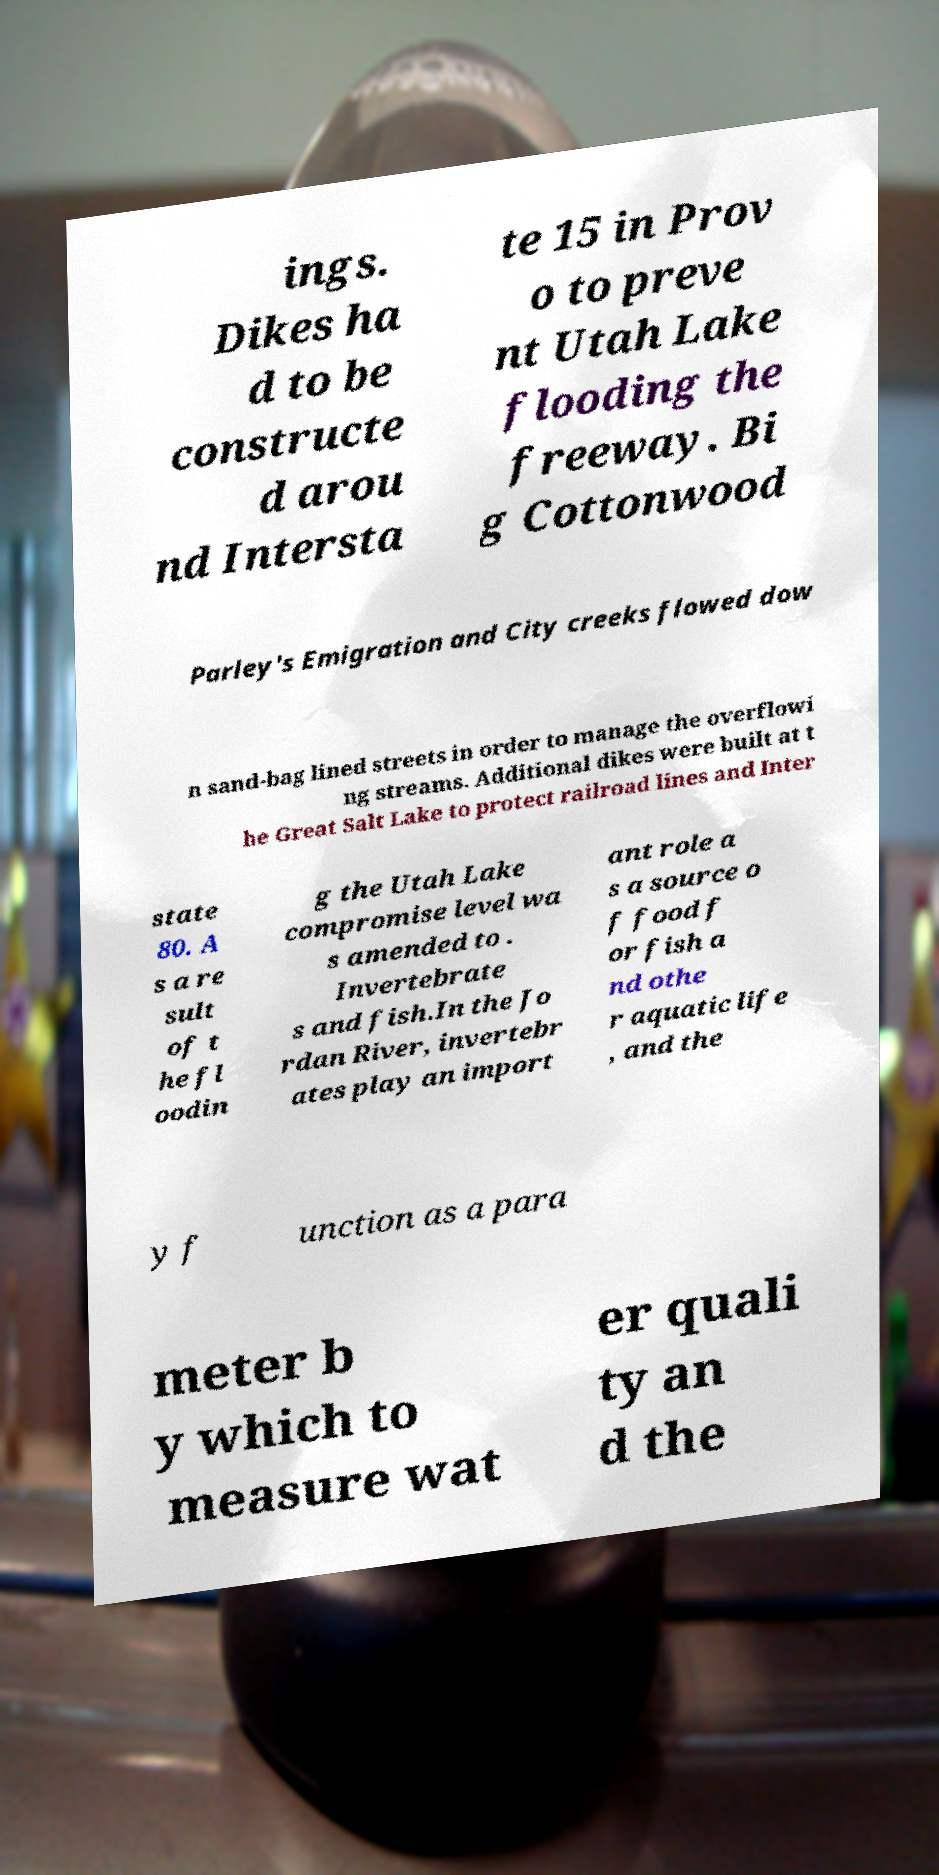Please read and relay the text visible in this image. What does it say? ings. Dikes ha d to be constructe d arou nd Intersta te 15 in Prov o to preve nt Utah Lake flooding the freeway. Bi g Cottonwood Parley's Emigration and City creeks flowed dow n sand-bag lined streets in order to manage the overflowi ng streams. Additional dikes were built at t he Great Salt Lake to protect railroad lines and Inter state 80. A s a re sult of t he fl oodin g the Utah Lake compromise level wa s amended to . Invertebrate s and fish.In the Jo rdan River, invertebr ates play an import ant role a s a source o f food f or fish a nd othe r aquatic life , and the y f unction as a para meter b y which to measure wat er quali ty an d the 